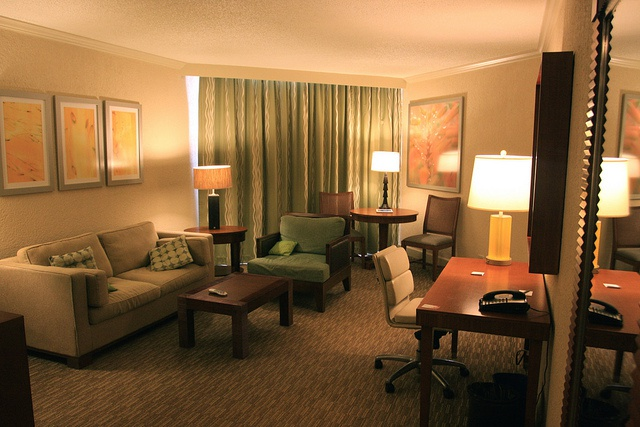Describe the objects in this image and their specific colors. I can see couch in tan, maroon, black, and olive tones, chair in tan, black, and olive tones, chair in tan, black, and maroon tones, chair in tan, maroon, black, and brown tones, and chair in tan, maroon, black, and brown tones in this image. 